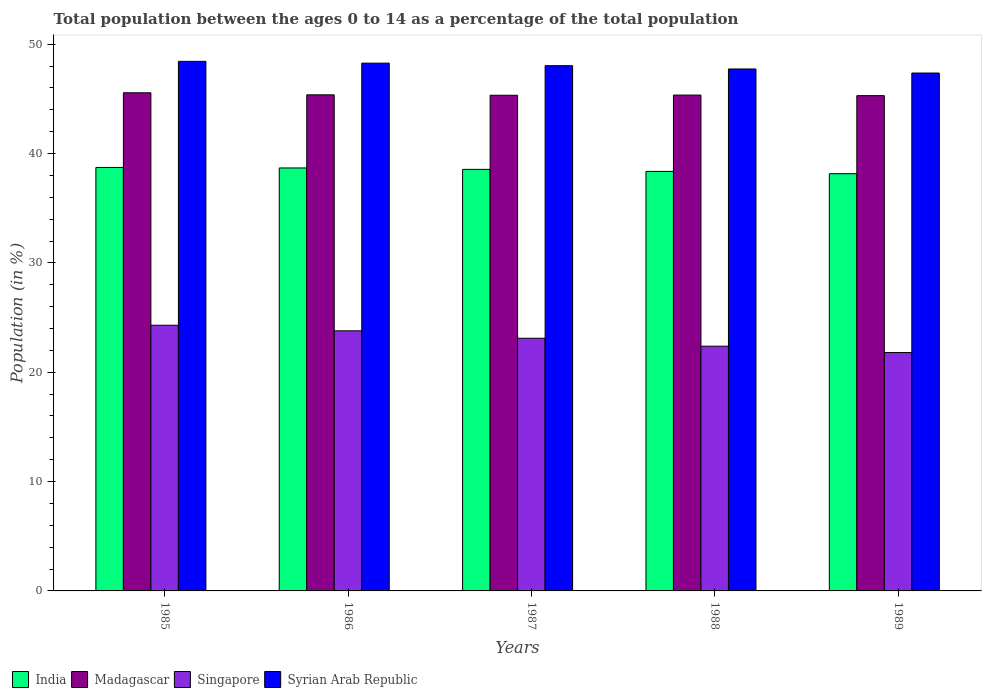How many groups of bars are there?
Give a very brief answer. 5. Are the number of bars per tick equal to the number of legend labels?
Give a very brief answer. Yes. How many bars are there on the 3rd tick from the left?
Ensure brevity in your answer.  4. How many bars are there on the 3rd tick from the right?
Your answer should be very brief. 4. In how many cases, is the number of bars for a given year not equal to the number of legend labels?
Give a very brief answer. 0. What is the percentage of the population ages 0 to 14 in India in 1989?
Ensure brevity in your answer.  38.16. Across all years, what is the maximum percentage of the population ages 0 to 14 in Madagascar?
Provide a succinct answer. 45.56. Across all years, what is the minimum percentage of the population ages 0 to 14 in Syrian Arab Republic?
Make the answer very short. 47.36. In which year was the percentage of the population ages 0 to 14 in Syrian Arab Republic minimum?
Your answer should be very brief. 1989. What is the total percentage of the population ages 0 to 14 in Singapore in the graph?
Offer a terse response. 115.37. What is the difference between the percentage of the population ages 0 to 14 in Madagascar in 1985 and that in 1989?
Offer a terse response. 0.26. What is the difference between the percentage of the population ages 0 to 14 in Syrian Arab Republic in 1988 and the percentage of the population ages 0 to 14 in Singapore in 1987?
Offer a terse response. 24.63. What is the average percentage of the population ages 0 to 14 in Syrian Arab Republic per year?
Your response must be concise. 47.97. In the year 1987, what is the difference between the percentage of the population ages 0 to 14 in India and percentage of the population ages 0 to 14 in Madagascar?
Provide a short and direct response. -6.78. In how many years, is the percentage of the population ages 0 to 14 in Singapore greater than 18?
Give a very brief answer. 5. What is the ratio of the percentage of the population ages 0 to 14 in India in 1986 to that in 1989?
Your response must be concise. 1.01. What is the difference between the highest and the second highest percentage of the population ages 0 to 14 in Madagascar?
Keep it short and to the point. 0.19. What is the difference between the highest and the lowest percentage of the population ages 0 to 14 in Syrian Arab Republic?
Offer a very short reply. 1.07. Is the sum of the percentage of the population ages 0 to 14 in Madagascar in 1985 and 1987 greater than the maximum percentage of the population ages 0 to 14 in India across all years?
Your answer should be very brief. Yes. Is it the case that in every year, the sum of the percentage of the population ages 0 to 14 in Syrian Arab Republic and percentage of the population ages 0 to 14 in Madagascar is greater than the sum of percentage of the population ages 0 to 14 in India and percentage of the population ages 0 to 14 in Singapore?
Provide a succinct answer. Yes. What does the 2nd bar from the left in 1987 represents?
Your response must be concise. Madagascar. What does the 1st bar from the right in 1985 represents?
Provide a short and direct response. Syrian Arab Republic. Is it the case that in every year, the sum of the percentage of the population ages 0 to 14 in Singapore and percentage of the population ages 0 to 14 in Madagascar is greater than the percentage of the population ages 0 to 14 in Syrian Arab Republic?
Provide a short and direct response. Yes. How many bars are there?
Provide a succinct answer. 20. Are all the bars in the graph horizontal?
Offer a terse response. No. Does the graph contain grids?
Your answer should be very brief. No. Where does the legend appear in the graph?
Your answer should be very brief. Bottom left. How are the legend labels stacked?
Your answer should be compact. Horizontal. What is the title of the graph?
Offer a terse response. Total population between the ages 0 to 14 as a percentage of the total population. Does "Cameroon" appear as one of the legend labels in the graph?
Your answer should be very brief. No. What is the label or title of the Y-axis?
Give a very brief answer. Population (in %). What is the Population (in %) of India in 1985?
Offer a very short reply. 38.73. What is the Population (in %) in Madagascar in 1985?
Offer a very short reply. 45.56. What is the Population (in %) of Singapore in 1985?
Your response must be concise. 24.3. What is the Population (in %) in Syrian Arab Republic in 1985?
Give a very brief answer. 48.43. What is the Population (in %) in India in 1986?
Your answer should be compact. 38.68. What is the Population (in %) in Madagascar in 1986?
Make the answer very short. 45.37. What is the Population (in %) in Singapore in 1986?
Ensure brevity in your answer.  23.79. What is the Population (in %) of Syrian Arab Republic in 1986?
Ensure brevity in your answer.  48.27. What is the Population (in %) in India in 1987?
Provide a succinct answer. 38.55. What is the Population (in %) in Madagascar in 1987?
Your answer should be compact. 45.33. What is the Population (in %) of Singapore in 1987?
Offer a very short reply. 23.11. What is the Population (in %) of Syrian Arab Republic in 1987?
Your answer should be compact. 48.03. What is the Population (in %) of India in 1988?
Give a very brief answer. 38.37. What is the Population (in %) in Madagascar in 1988?
Give a very brief answer. 45.35. What is the Population (in %) of Singapore in 1988?
Provide a short and direct response. 22.38. What is the Population (in %) of Syrian Arab Republic in 1988?
Keep it short and to the point. 47.73. What is the Population (in %) of India in 1989?
Offer a very short reply. 38.16. What is the Population (in %) in Madagascar in 1989?
Give a very brief answer. 45.29. What is the Population (in %) in Singapore in 1989?
Give a very brief answer. 21.8. What is the Population (in %) of Syrian Arab Republic in 1989?
Provide a short and direct response. 47.36. Across all years, what is the maximum Population (in %) in India?
Offer a terse response. 38.73. Across all years, what is the maximum Population (in %) of Madagascar?
Offer a terse response. 45.56. Across all years, what is the maximum Population (in %) in Singapore?
Your answer should be compact. 24.3. Across all years, what is the maximum Population (in %) of Syrian Arab Republic?
Offer a very short reply. 48.43. Across all years, what is the minimum Population (in %) in India?
Offer a terse response. 38.16. Across all years, what is the minimum Population (in %) in Madagascar?
Offer a terse response. 45.29. Across all years, what is the minimum Population (in %) in Singapore?
Keep it short and to the point. 21.8. Across all years, what is the minimum Population (in %) of Syrian Arab Republic?
Your response must be concise. 47.36. What is the total Population (in %) of India in the graph?
Offer a very short reply. 192.48. What is the total Population (in %) of Madagascar in the graph?
Offer a terse response. 226.9. What is the total Population (in %) of Singapore in the graph?
Keep it short and to the point. 115.37. What is the total Population (in %) of Syrian Arab Republic in the graph?
Offer a terse response. 239.83. What is the difference between the Population (in %) of India in 1985 and that in 1986?
Ensure brevity in your answer.  0.05. What is the difference between the Population (in %) of Madagascar in 1985 and that in 1986?
Keep it short and to the point. 0.19. What is the difference between the Population (in %) in Singapore in 1985 and that in 1986?
Your answer should be very brief. 0.51. What is the difference between the Population (in %) of Syrian Arab Republic in 1985 and that in 1986?
Offer a terse response. 0.16. What is the difference between the Population (in %) of India in 1985 and that in 1987?
Offer a very short reply. 0.17. What is the difference between the Population (in %) of Madagascar in 1985 and that in 1987?
Your response must be concise. 0.23. What is the difference between the Population (in %) of Singapore in 1985 and that in 1987?
Offer a terse response. 1.19. What is the difference between the Population (in %) in Syrian Arab Republic in 1985 and that in 1987?
Offer a terse response. 0.4. What is the difference between the Population (in %) of India in 1985 and that in 1988?
Give a very brief answer. 0.36. What is the difference between the Population (in %) in Madagascar in 1985 and that in 1988?
Your answer should be compact. 0.21. What is the difference between the Population (in %) of Singapore in 1985 and that in 1988?
Your answer should be very brief. 1.91. What is the difference between the Population (in %) of Syrian Arab Republic in 1985 and that in 1988?
Ensure brevity in your answer.  0.7. What is the difference between the Population (in %) in India in 1985 and that in 1989?
Your answer should be very brief. 0.57. What is the difference between the Population (in %) of Madagascar in 1985 and that in 1989?
Offer a very short reply. 0.26. What is the difference between the Population (in %) in Singapore in 1985 and that in 1989?
Ensure brevity in your answer.  2.5. What is the difference between the Population (in %) of Syrian Arab Republic in 1985 and that in 1989?
Offer a very short reply. 1.07. What is the difference between the Population (in %) of India in 1986 and that in 1987?
Keep it short and to the point. 0.13. What is the difference between the Population (in %) in Madagascar in 1986 and that in 1987?
Make the answer very short. 0.04. What is the difference between the Population (in %) in Singapore in 1986 and that in 1987?
Make the answer very short. 0.68. What is the difference between the Population (in %) of Syrian Arab Republic in 1986 and that in 1987?
Keep it short and to the point. 0.23. What is the difference between the Population (in %) of India in 1986 and that in 1988?
Your answer should be very brief. 0.31. What is the difference between the Population (in %) of Madagascar in 1986 and that in 1988?
Offer a terse response. 0.02. What is the difference between the Population (in %) of Singapore in 1986 and that in 1988?
Offer a very short reply. 1.41. What is the difference between the Population (in %) of Syrian Arab Republic in 1986 and that in 1988?
Offer a very short reply. 0.53. What is the difference between the Population (in %) of India in 1986 and that in 1989?
Provide a succinct answer. 0.53. What is the difference between the Population (in %) of Madagascar in 1986 and that in 1989?
Provide a short and direct response. 0.07. What is the difference between the Population (in %) in Singapore in 1986 and that in 1989?
Your answer should be very brief. 1.99. What is the difference between the Population (in %) in Syrian Arab Republic in 1986 and that in 1989?
Offer a very short reply. 0.9. What is the difference between the Population (in %) in India in 1987 and that in 1988?
Keep it short and to the point. 0.19. What is the difference between the Population (in %) of Madagascar in 1987 and that in 1988?
Give a very brief answer. -0.02. What is the difference between the Population (in %) in Singapore in 1987 and that in 1988?
Keep it short and to the point. 0.72. What is the difference between the Population (in %) of Syrian Arab Republic in 1987 and that in 1988?
Offer a very short reply. 0.3. What is the difference between the Population (in %) of India in 1987 and that in 1989?
Give a very brief answer. 0.4. What is the difference between the Population (in %) of Madagascar in 1987 and that in 1989?
Keep it short and to the point. 0.03. What is the difference between the Population (in %) of Singapore in 1987 and that in 1989?
Your response must be concise. 1.31. What is the difference between the Population (in %) of Syrian Arab Republic in 1987 and that in 1989?
Ensure brevity in your answer.  0.67. What is the difference between the Population (in %) in India in 1988 and that in 1989?
Keep it short and to the point. 0.21. What is the difference between the Population (in %) of Madagascar in 1988 and that in 1989?
Your answer should be compact. 0.05. What is the difference between the Population (in %) of Singapore in 1988 and that in 1989?
Your response must be concise. 0.58. What is the difference between the Population (in %) of Syrian Arab Republic in 1988 and that in 1989?
Provide a short and direct response. 0.37. What is the difference between the Population (in %) in India in 1985 and the Population (in %) in Madagascar in 1986?
Make the answer very short. -6.64. What is the difference between the Population (in %) of India in 1985 and the Population (in %) of Singapore in 1986?
Provide a short and direct response. 14.94. What is the difference between the Population (in %) of India in 1985 and the Population (in %) of Syrian Arab Republic in 1986?
Your answer should be very brief. -9.54. What is the difference between the Population (in %) in Madagascar in 1985 and the Population (in %) in Singapore in 1986?
Offer a terse response. 21.77. What is the difference between the Population (in %) of Madagascar in 1985 and the Population (in %) of Syrian Arab Republic in 1986?
Your answer should be compact. -2.71. What is the difference between the Population (in %) in Singapore in 1985 and the Population (in %) in Syrian Arab Republic in 1986?
Provide a succinct answer. -23.97. What is the difference between the Population (in %) of India in 1985 and the Population (in %) of Madagascar in 1987?
Give a very brief answer. -6.6. What is the difference between the Population (in %) of India in 1985 and the Population (in %) of Singapore in 1987?
Provide a short and direct response. 15.62. What is the difference between the Population (in %) in India in 1985 and the Population (in %) in Syrian Arab Republic in 1987?
Offer a very short reply. -9.31. What is the difference between the Population (in %) of Madagascar in 1985 and the Population (in %) of Singapore in 1987?
Your answer should be very brief. 22.45. What is the difference between the Population (in %) of Madagascar in 1985 and the Population (in %) of Syrian Arab Republic in 1987?
Your response must be concise. -2.48. What is the difference between the Population (in %) of Singapore in 1985 and the Population (in %) of Syrian Arab Republic in 1987?
Make the answer very short. -23.74. What is the difference between the Population (in %) in India in 1985 and the Population (in %) in Madagascar in 1988?
Keep it short and to the point. -6.62. What is the difference between the Population (in %) in India in 1985 and the Population (in %) in Singapore in 1988?
Keep it short and to the point. 16.35. What is the difference between the Population (in %) of India in 1985 and the Population (in %) of Syrian Arab Republic in 1988?
Your answer should be compact. -9.01. What is the difference between the Population (in %) of Madagascar in 1985 and the Population (in %) of Singapore in 1988?
Provide a short and direct response. 23.17. What is the difference between the Population (in %) of Madagascar in 1985 and the Population (in %) of Syrian Arab Republic in 1988?
Ensure brevity in your answer.  -2.18. What is the difference between the Population (in %) in Singapore in 1985 and the Population (in %) in Syrian Arab Republic in 1988?
Your answer should be very brief. -23.44. What is the difference between the Population (in %) of India in 1985 and the Population (in %) of Madagascar in 1989?
Offer a terse response. -6.57. What is the difference between the Population (in %) in India in 1985 and the Population (in %) in Singapore in 1989?
Your response must be concise. 16.93. What is the difference between the Population (in %) in India in 1985 and the Population (in %) in Syrian Arab Republic in 1989?
Your answer should be compact. -8.63. What is the difference between the Population (in %) in Madagascar in 1985 and the Population (in %) in Singapore in 1989?
Your answer should be compact. 23.76. What is the difference between the Population (in %) in Madagascar in 1985 and the Population (in %) in Syrian Arab Republic in 1989?
Provide a succinct answer. -1.81. What is the difference between the Population (in %) in Singapore in 1985 and the Population (in %) in Syrian Arab Republic in 1989?
Offer a terse response. -23.07. What is the difference between the Population (in %) in India in 1986 and the Population (in %) in Madagascar in 1987?
Make the answer very short. -6.65. What is the difference between the Population (in %) of India in 1986 and the Population (in %) of Singapore in 1987?
Provide a succinct answer. 15.57. What is the difference between the Population (in %) in India in 1986 and the Population (in %) in Syrian Arab Republic in 1987?
Provide a succinct answer. -9.35. What is the difference between the Population (in %) in Madagascar in 1986 and the Population (in %) in Singapore in 1987?
Keep it short and to the point. 22.26. What is the difference between the Population (in %) of Madagascar in 1986 and the Population (in %) of Syrian Arab Republic in 1987?
Keep it short and to the point. -2.67. What is the difference between the Population (in %) in Singapore in 1986 and the Population (in %) in Syrian Arab Republic in 1987?
Provide a short and direct response. -24.25. What is the difference between the Population (in %) of India in 1986 and the Population (in %) of Madagascar in 1988?
Keep it short and to the point. -6.67. What is the difference between the Population (in %) in India in 1986 and the Population (in %) in Singapore in 1988?
Offer a very short reply. 16.3. What is the difference between the Population (in %) in India in 1986 and the Population (in %) in Syrian Arab Republic in 1988?
Offer a terse response. -9.05. What is the difference between the Population (in %) of Madagascar in 1986 and the Population (in %) of Singapore in 1988?
Your response must be concise. 22.99. What is the difference between the Population (in %) in Madagascar in 1986 and the Population (in %) in Syrian Arab Republic in 1988?
Your answer should be compact. -2.37. What is the difference between the Population (in %) of Singapore in 1986 and the Population (in %) of Syrian Arab Republic in 1988?
Your answer should be very brief. -23.95. What is the difference between the Population (in %) of India in 1986 and the Population (in %) of Madagascar in 1989?
Give a very brief answer. -6.61. What is the difference between the Population (in %) of India in 1986 and the Population (in %) of Singapore in 1989?
Give a very brief answer. 16.88. What is the difference between the Population (in %) of India in 1986 and the Population (in %) of Syrian Arab Republic in 1989?
Offer a terse response. -8.68. What is the difference between the Population (in %) of Madagascar in 1986 and the Population (in %) of Singapore in 1989?
Provide a short and direct response. 23.57. What is the difference between the Population (in %) of Madagascar in 1986 and the Population (in %) of Syrian Arab Republic in 1989?
Your answer should be very brief. -1.99. What is the difference between the Population (in %) of Singapore in 1986 and the Population (in %) of Syrian Arab Republic in 1989?
Provide a succinct answer. -23.58. What is the difference between the Population (in %) in India in 1987 and the Population (in %) in Madagascar in 1988?
Keep it short and to the point. -6.79. What is the difference between the Population (in %) of India in 1987 and the Population (in %) of Singapore in 1988?
Provide a short and direct response. 16.17. What is the difference between the Population (in %) in India in 1987 and the Population (in %) in Syrian Arab Republic in 1988?
Keep it short and to the point. -9.18. What is the difference between the Population (in %) of Madagascar in 1987 and the Population (in %) of Singapore in 1988?
Offer a very short reply. 22.95. What is the difference between the Population (in %) in Madagascar in 1987 and the Population (in %) in Syrian Arab Republic in 1988?
Offer a very short reply. -2.4. What is the difference between the Population (in %) in Singapore in 1987 and the Population (in %) in Syrian Arab Republic in 1988?
Provide a short and direct response. -24.63. What is the difference between the Population (in %) of India in 1987 and the Population (in %) of Madagascar in 1989?
Provide a succinct answer. -6.74. What is the difference between the Population (in %) of India in 1987 and the Population (in %) of Singapore in 1989?
Offer a terse response. 16.75. What is the difference between the Population (in %) in India in 1987 and the Population (in %) in Syrian Arab Republic in 1989?
Provide a succinct answer. -8.81. What is the difference between the Population (in %) in Madagascar in 1987 and the Population (in %) in Singapore in 1989?
Provide a short and direct response. 23.53. What is the difference between the Population (in %) of Madagascar in 1987 and the Population (in %) of Syrian Arab Republic in 1989?
Your answer should be compact. -2.03. What is the difference between the Population (in %) in Singapore in 1987 and the Population (in %) in Syrian Arab Republic in 1989?
Your response must be concise. -24.26. What is the difference between the Population (in %) in India in 1988 and the Population (in %) in Madagascar in 1989?
Make the answer very short. -6.93. What is the difference between the Population (in %) of India in 1988 and the Population (in %) of Singapore in 1989?
Your response must be concise. 16.57. What is the difference between the Population (in %) of India in 1988 and the Population (in %) of Syrian Arab Republic in 1989?
Offer a terse response. -9. What is the difference between the Population (in %) of Madagascar in 1988 and the Population (in %) of Singapore in 1989?
Offer a very short reply. 23.55. What is the difference between the Population (in %) of Madagascar in 1988 and the Population (in %) of Syrian Arab Republic in 1989?
Keep it short and to the point. -2.02. What is the difference between the Population (in %) in Singapore in 1988 and the Population (in %) in Syrian Arab Republic in 1989?
Your answer should be compact. -24.98. What is the average Population (in %) of India per year?
Your answer should be compact. 38.5. What is the average Population (in %) in Madagascar per year?
Ensure brevity in your answer.  45.38. What is the average Population (in %) of Singapore per year?
Keep it short and to the point. 23.07. What is the average Population (in %) in Syrian Arab Republic per year?
Provide a succinct answer. 47.97. In the year 1985, what is the difference between the Population (in %) of India and Population (in %) of Madagascar?
Your answer should be compact. -6.83. In the year 1985, what is the difference between the Population (in %) of India and Population (in %) of Singapore?
Provide a succinct answer. 14.43. In the year 1985, what is the difference between the Population (in %) in India and Population (in %) in Syrian Arab Republic?
Your answer should be compact. -9.7. In the year 1985, what is the difference between the Population (in %) of Madagascar and Population (in %) of Singapore?
Offer a terse response. 21.26. In the year 1985, what is the difference between the Population (in %) in Madagascar and Population (in %) in Syrian Arab Republic?
Provide a short and direct response. -2.87. In the year 1985, what is the difference between the Population (in %) in Singapore and Population (in %) in Syrian Arab Republic?
Your answer should be very brief. -24.13. In the year 1986, what is the difference between the Population (in %) in India and Population (in %) in Madagascar?
Make the answer very short. -6.69. In the year 1986, what is the difference between the Population (in %) of India and Population (in %) of Singapore?
Your answer should be very brief. 14.89. In the year 1986, what is the difference between the Population (in %) in India and Population (in %) in Syrian Arab Republic?
Give a very brief answer. -9.58. In the year 1986, what is the difference between the Population (in %) in Madagascar and Population (in %) in Singapore?
Provide a short and direct response. 21.58. In the year 1986, what is the difference between the Population (in %) in Madagascar and Population (in %) in Syrian Arab Republic?
Your answer should be compact. -2.9. In the year 1986, what is the difference between the Population (in %) of Singapore and Population (in %) of Syrian Arab Republic?
Keep it short and to the point. -24.48. In the year 1987, what is the difference between the Population (in %) in India and Population (in %) in Madagascar?
Make the answer very short. -6.78. In the year 1987, what is the difference between the Population (in %) of India and Population (in %) of Singapore?
Provide a short and direct response. 15.45. In the year 1987, what is the difference between the Population (in %) of India and Population (in %) of Syrian Arab Republic?
Ensure brevity in your answer.  -9.48. In the year 1987, what is the difference between the Population (in %) in Madagascar and Population (in %) in Singapore?
Your response must be concise. 22.22. In the year 1987, what is the difference between the Population (in %) in Madagascar and Population (in %) in Syrian Arab Republic?
Your answer should be compact. -2.7. In the year 1987, what is the difference between the Population (in %) of Singapore and Population (in %) of Syrian Arab Republic?
Provide a short and direct response. -24.93. In the year 1988, what is the difference between the Population (in %) of India and Population (in %) of Madagascar?
Your answer should be very brief. -6.98. In the year 1988, what is the difference between the Population (in %) in India and Population (in %) in Singapore?
Your answer should be compact. 15.99. In the year 1988, what is the difference between the Population (in %) of India and Population (in %) of Syrian Arab Republic?
Ensure brevity in your answer.  -9.37. In the year 1988, what is the difference between the Population (in %) of Madagascar and Population (in %) of Singapore?
Keep it short and to the point. 22.96. In the year 1988, what is the difference between the Population (in %) of Madagascar and Population (in %) of Syrian Arab Republic?
Ensure brevity in your answer.  -2.39. In the year 1988, what is the difference between the Population (in %) of Singapore and Population (in %) of Syrian Arab Republic?
Provide a succinct answer. -25.35. In the year 1989, what is the difference between the Population (in %) in India and Population (in %) in Madagascar?
Provide a short and direct response. -7.14. In the year 1989, what is the difference between the Population (in %) of India and Population (in %) of Singapore?
Offer a terse response. 16.36. In the year 1989, what is the difference between the Population (in %) in India and Population (in %) in Syrian Arab Republic?
Your answer should be compact. -9.21. In the year 1989, what is the difference between the Population (in %) in Madagascar and Population (in %) in Singapore?
Offer a very short reply. 23.49. In the year 1989, what is the difference between the Population (in %) in Madagascar and Population (in %) in Syrian Arab Republic?
Your response must be concise. -2.07. In the year 1989, what is the difference between the Population (in %) of Singapore and Population (in %) of Syrian Arab Republic?
Offer a terse response. -25.56. What is the ratio of the Population (in %) in India in 1985 to that in 1986?
Your answer should be compact. 1. What is the ratio of the Population (in %) in Singapore in 1985 to that in 1986?
Provide a short and direct response. 1.02. What is the ratio of the Population (in %) of India in 1985 to that in 1987?
Keep it short and to the point. 1. What is the ratio of the Population (in %) in Madagascar in 1985 to that in 1987?
Provide a short and direct response. 1. What is the ratio of the Population (in %) of Singapore in 1985 to that in 1987?
Your answer should be very brief. 1.05. What is the ratio of the Population (in %) in Syrian Arab Republic in 1985 to that in 1987?
Your answer should be very brief. 1.01. What is the ratio of the Population (in %) of India in 1985 to that in 1988?
Your answer should be very brief. 1.01. What is the ratio of the Population (in %) in Singapore in 1985 to that in 1988?
Your response must be concise. 1.09. What is the ratio of the Population (in %) in Syrian Arab Republic in 1985 to that in 1988?
Give a very brief answer. 1.01. What is the ratio of the Population (in %) in Madagascar in 1985 to that in 1989?
Your answer should be very brief. 1.01. What is the ratio of the Population (in %) in Singapore in 1985 to that in 1989?
Provide a succinct answer. 1.11. What is the ratio of the Population (in %) of Syrian Arab Republic in 1985 to that in 1989?
Ensure brevity in your answer.  1.02. What is the ratio of the Population (in %) of Singapore in 1986 to that in 1987?
Provide a short and direct response. 1.03. What is the ratio of the Population (in %) in Syrian Arab Republic in 1986 to that in 1987?
Your answer should be compact. 1. What is the ratio of the Population (in %) in India in 1986 to that in 1988?
Give a very brief answer. 1.01. What is the ratio of the Population (in %) of Singapore in 1986 to that in 1988?
Your answer should be very brief. 1.06. What is the ratio of the Population (in %) of Syrian Arab Republic in 1986 to that in 1988?
Provide a succinct answer. 1.01. What is the ratio of the Population (in %) of India in 1986 to that in 1989?
Provide a short and direct response. 1.01. What is the ratio of the Population (in %) of Madagascar in 1986 to that in 1989?
Provide a succinct answer. 1. What is the ratio of the Population (in %) of Singapore in 1986 to that in 1989?
Your response must be concise. 1.09. What is the ratio of the Population (in %) of Syrian Arab Republic in 1986 to that in 1989?
Your response must be concise. 1.02. What is the ratio of the Population (in %) in India in 1987 to that in 1988?
Provide a succinct answer. 1. What is the ratio of the Population (in %) of Madagascar in 1987 to that in 1988?
Provide a short and direct response. 1. What is the ratio of the Population (in %) of Singapore in 1987 to that in 1988?
Your answer should be very brief. 1.03. What is the ratio of the Population (in %) in India in 1987 to that in 1989?
Your answer should be very brief. 1.01. What is the ratio of the Population (in %) of Madagascar in 1987 to that in 1989?
Your answer should be compact. 1. What is the ratio of the Population (in %) of Singapore in 1987 to that in 1989?
Your answer should be compact. 1.06. What is the ratio of the Population (in %) in Syrian Arab Republic in 1987 to that in 1989?
Your response must be concise. 1.01. What is the ratio of the Population (in %) in India in 1988 to that in 1989?
Your answer should be compact. 1.01. What is the ratio of the Population (in %) of Singapore in 1988 to that in 1989?
Your answer should be compact. 1.03. What is the difference between the highest and the second highest Population (in %) of India?
Offer a terse response. 0.05. What is the difference between the highest and the second highest Population (in %) of Madagascar?
Offer a very short reply. 0.19. What is the difference between the highest and the second highest Population (in %) of Singapore?
Make the answer very short. 0.51. What is the difference between the highest and the second highest Population (in %) of Syrian Arab Republic?
Your answer should be compact. 0.16. What is the difference between the highest and the lowest Population (in %) in India?
Provide a short and direct response. 0.57. What is the difference between the highest and the lowest Population (in %) of Madagascar?
Provide a short and direct response. 0.26. What is the difference between the highest and the lowest Population (in %) of Singapore?
Offer a very short reply. 2.5. What is the difference between the highest and the lowest Population (in %) in Syrian Arab Republic?
Make the answer very short. 1.07. 